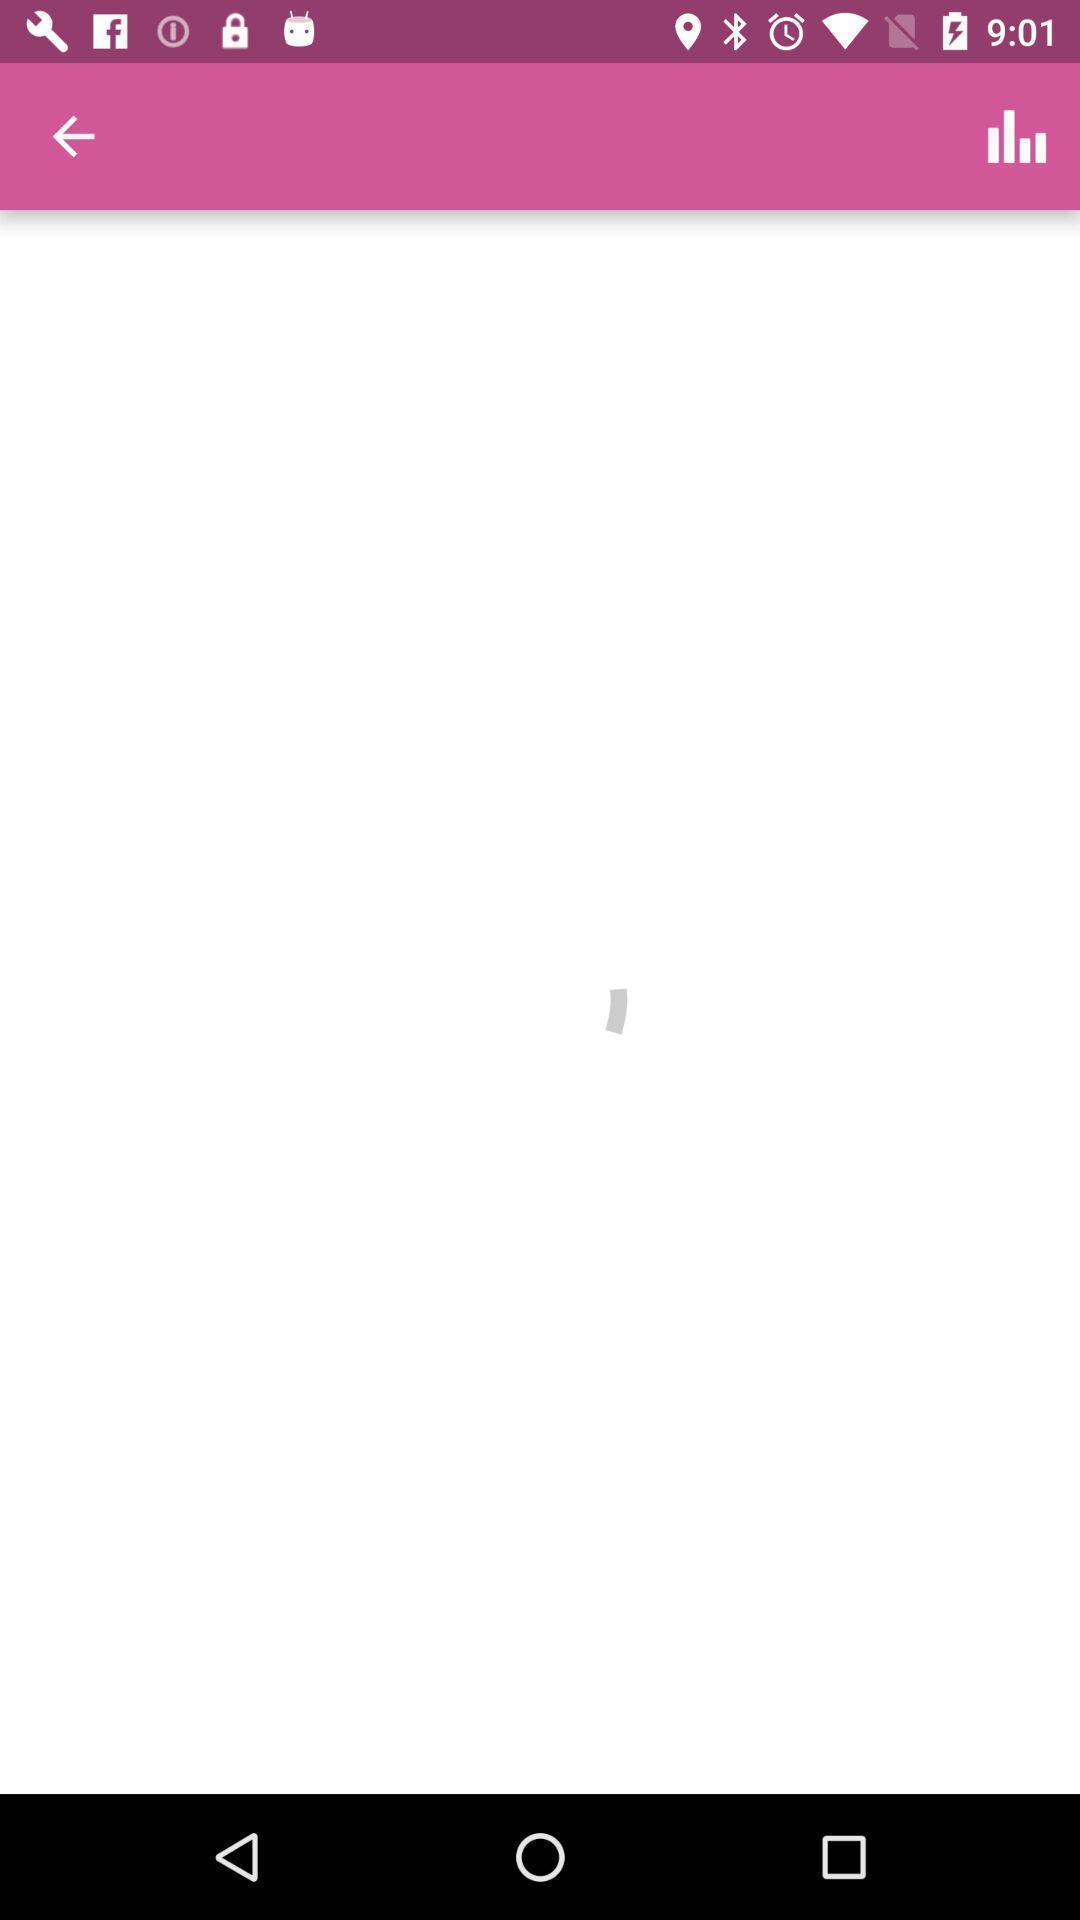What can you discern from this picture? Page showing blank page with back option. 